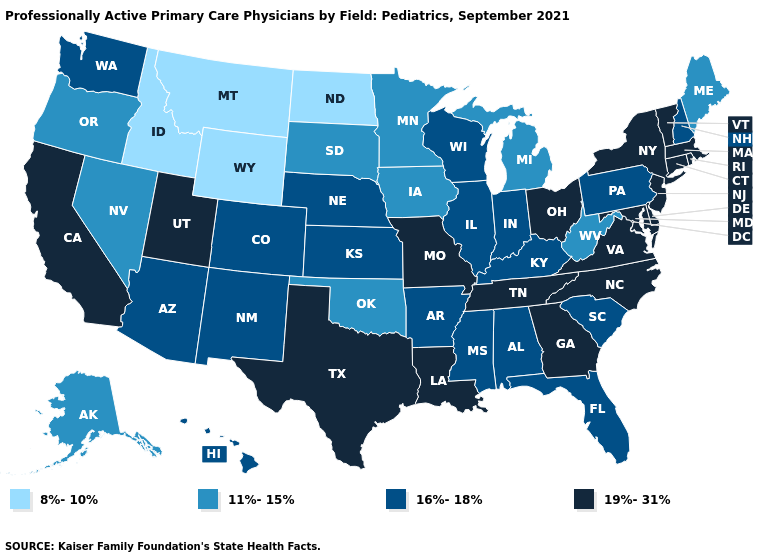What is the value of Wisconsin?
Short answer required. 16%-18%. Name the states that have a value in the range 19%-31%?
Answer briefly. California, Connecticut, Delaware, Georgia, Louisiana, Maryland, Massachusetts, Missouri, New Jersey, New York, North Carolina, Ohio, Rhode Island, Tennessee, Texas, Utah, Vermont, Virginia. Name the states that have a value in the range 19%-31%?
Quick response, please. California, Connecticut, Delaware, Georgia, Louisiana, Maryland, Massachusetts, Missouri, New Jersey, New York, North Carolina, Ohio, Rhode Island, Tennessee, Texas, Utah, Vermont, Virginia. What is the value of New York?
Be succinct. 19%-31%. What is the value of Kansas?
Be succinct. 16%-18%. Among the states that border Virginia , which have the lowest value?
Write a very short answer. West Virginia. Name the states that have a value in the range 19%-31%?
Write a very short answer. California, Connecticut, Delaware, Georgia, Louisiana, Maryland, Massachusetts, Missouri, New Jersey, New York, North Carolina, Ohio, Rhode Island, Tennessee, Texas, Utah, Vermont, Virginia. Among the states that border Arkansas , does Mississippi have the highest value?
Quick response, please. No. Name the states that have a value in the range 16%-18%?
Write a very short answer. Alabama, Arizona, Arkansas, Colorado, Florida, Hawaii, Illinois, Indiana, Kansas, Kentucky, Mississippi, Nebraska, New Hampshire, New Mexico, Pennsylvania, South Carolina, Washington, Wisconsin. Name the states that have a value in the range 16%-18%?
Concise answer only. Alabama, Arizona, Arkansas, Colorado, Florida, Hawaii, Illinois, Indiana, Kansas, Kentucky, Mississippi, Nebraska, New Hampshire, New Mexico, Pennsylvania, South Carolina, Washington, Wisconsin. Among the states that border New York , does New Jersey have the highest value?
Write a very short answer. Yes. Which states have the lowest value in the USA?
Answer briefly. Idaho, Montana, North Dakota, Wyoming. What is the value of Georgia?
Be succinct. 19%-31%. Name the states that have a value in the range 16%-18%?
Answer briefly. Alabama, Arizona, Arkansas, Colorado, Florida, Hawaii, Illinois, Indiana, Kansas, Kentucky, Mississippi, Nebraska, New Hampshire, New Mexico, Pennsylvania, South Carolina, Washington, Wisconsin. 